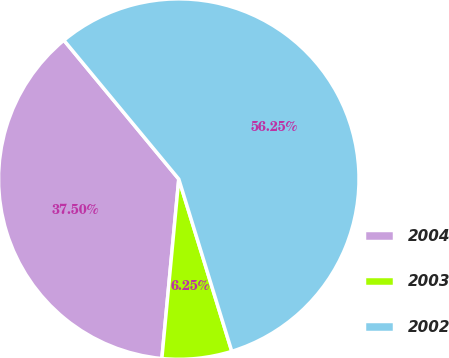<chart> <loc_0><loc_0><loc_500><loc_500><pie_chart><fcel>2004<fcel>2003<fcel>2002<nl><fcel>37.5%<fcel>6.25%<fcel>56.25%<nl></chart> 